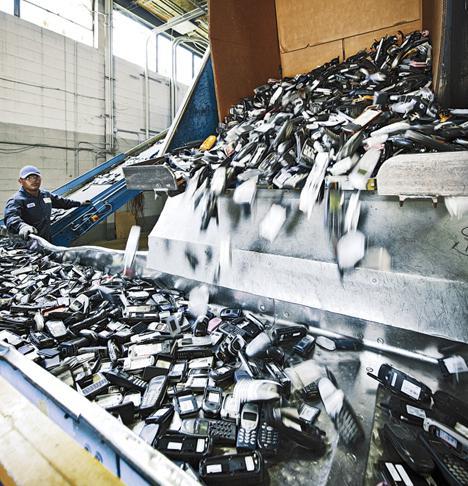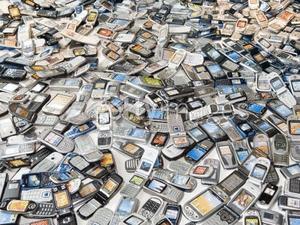The first image is the image on the left, the second image is the image on the right. Evaluate the accuracy of this statement regarding the images: "There is exactly one person in the left image.". Is it true? Answer yes or no. Yes. The first image is the image on the left, the second image is the image on the right. Assess this claim about the two images: "There are cell phone being pushed off a metal shelve to land on a conveyor belt.". Correct or not? Answer yes or no. Yes. 